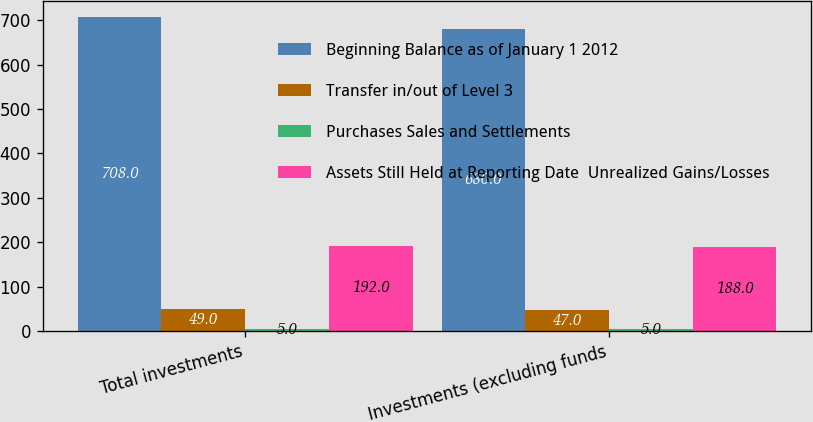Convert chart to OTSL. <chart><loc_0><loc_0><loc_500><loc_500><stacked_bar_chart><ecel><fcel>Total investments<fcel>Investments (excluding funds<nl><fcel>Beginning Balance as of January 1 2012<fcel>708<fcel>680<nl><fcel>Transfer in/out of Level 3<fcel>49<fcel>47<nl><fcel>Purchases Sales and Settlements<fcel>5<fcel>5<nl><fcel>Assets Still Held at Reporting Date  Unrealized Gains/Losses<fcel>192<fcel>188<nl></chart> 